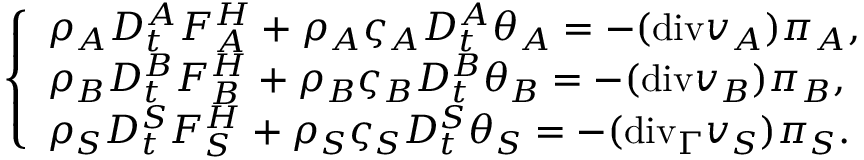Convert formula to latex. <formula><loc_0><loc_0><loc_500><loc_500>\left \{ \begin{array} { l l } { \rho _ { A } D _ { t } ^ { A } F _ { A } ^ { H } + \rho _ { A } \varsigma _ { A } D _ { t } ^ { A } \theta _ { A } = - ( { d i v } v _ { A } ) \pi _ { A } , } \\ { \rho _ { B } D _ { t } ^ { B } F _ { B } ^ { H } + \rho _ { B } \varsigma _ { B } D _ { t } ^ { B } \theta _ { B } = - ( { d i v } v _ { B } ) \pi _ { B } , } \\ { \rho _ { S } D _ { t } ^ { S } F _ { S } ^ { H } + \rho _ { S } \varsigma _ { S } D _ { t } ^ { S } \theta _ { S } = - ( { d i v } _ { \Gamma } v _ { S } ) \pi _ { S } . } \end{array}</formula> 